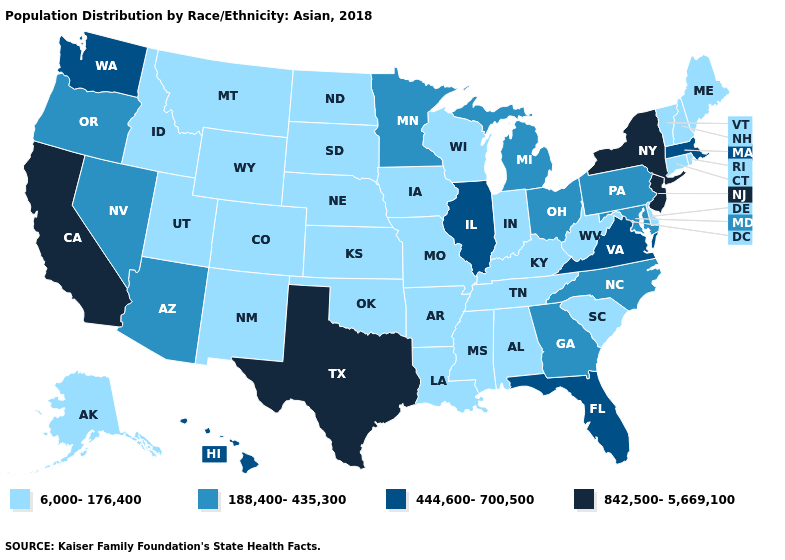What is the value of Washington?
Quick response, please. 444,600-700,500. What is the lowest value in the MidWest?
Be succinct. 6,000-176,400. What is the value of Maryland?
Concise answer only. 188,400-435,300. Among the states that border Colorado , which have the lowest value?
Give a very brief answer. Kansas, Nebraska, New Mexico, Oklahoma, Utah, Wyoming. Name the states that have a value in the range 6,000-176,400?
Short answer required. Alabama, Alaska, Arkansas, Colorado, Connecticut, Delaware, Idaho, Indiana, Iowa, Kansas, Kentucky, Louisiana, Maine, Mississippi, Missouri, Montana, Nebraska, New Hampshire, New Mexico, North Dakota, Oklahoma, Rhode Island, South Carolina, South Dakota, Tennessee, Utah, Vermont, West Virginia, Wisconsin, Wyoming. Among the states that border Alabama , does Florida have the lowest value?
Be succinct. No. What is the value of Minnesota?
Give a very brief answer. 188,400-435,300. What is the value of Alaska?
Write a very short answer. 6,000-176,400. Does Montana have the lowest value in the USA?
Be succinct. Yes. What is the lowest value in the Northeast?
Short answer required. 6,000-176,400. Name the states that have a value in the range 188,400-435,300?
Be succinct. Arizona, Georgia, Maryland, Michigan, Minnesota, Nevada, North Carolina, Ohio, Oregon, Pennsylvania. Among the states that border Wisconsin , which have the lowest value?
Give a very brief answer. Iowa. What is the lowest value in the West?
Short answer required. 6,000-176,400. What is the highest value in the South ?
Short answer required. 842,500-5,669,100. What is the value of Vermont?
Write a very short answer. 6,000-176,400. 